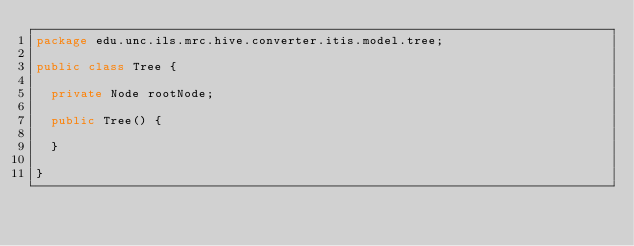<code> <loc_0><loc_0><loc_500><loc_500><_Java_>package edu.unc.ils.mrc.hive.converter.itis.model.tree;

public class Tree {
	
	private Node rootNode;
	
	public Tree() {
		
	}

}
</code> 